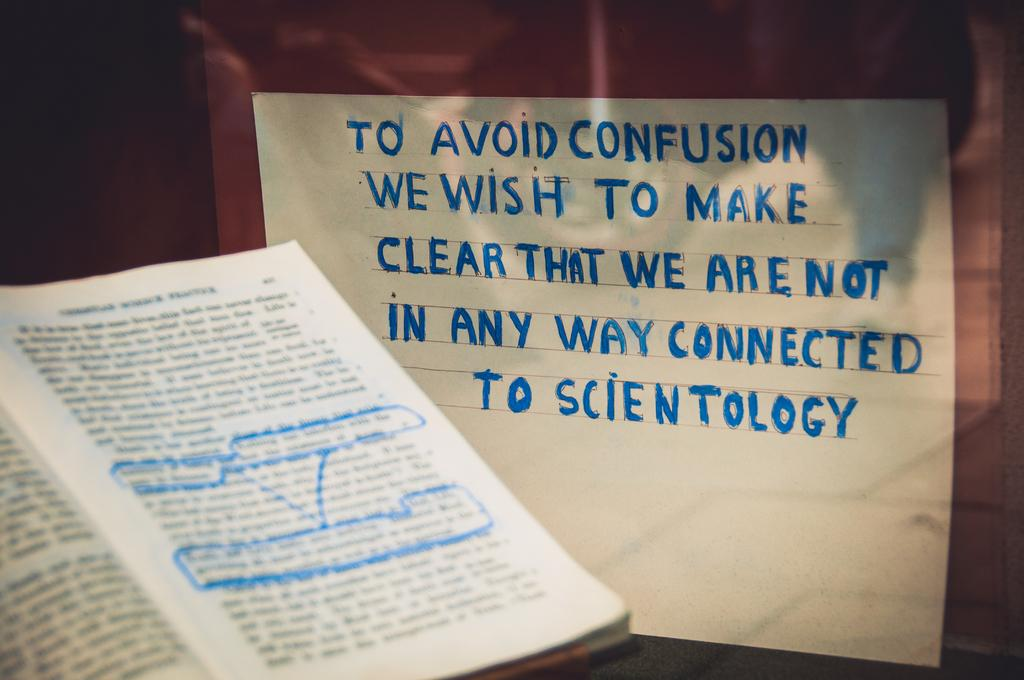What is the main object in the image? There is an opened book in the image. Where is the book located? The book is on the left side of the image. What else can be seen in the image besides the book? There is a white sheet in the image. Where is the white sheet located? The white sheet is on the right side of the image. What is written or printed on the white sheet? There is text on the white sheet. Can you tell me how many hens are on the white sheet in the image? There are no hens present in the image; it only features a white sheet with text on it. 